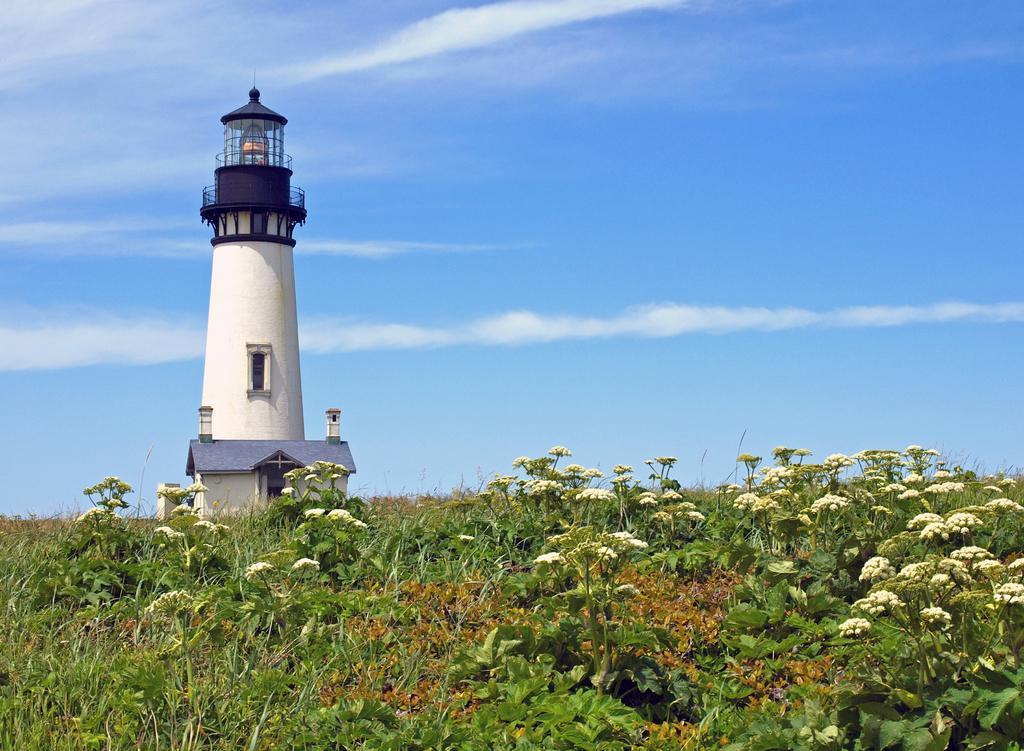Describe this image in one or two sentences. In the foreground of the picture there are plants and flowers. In the center there is a lighthouse. Sky is sunny. 